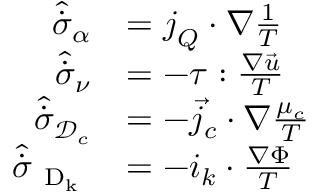Convert formula to latex. <formula><loc_0><loc_0><loc_500><loc_500>\begin{array} { r l } { \hat { \dot { \sigma } } _ { \alpha } } & { = j _ { Q } \cdot { \nabla } { \frac { 1 } { T } } } \\ { \hat { \dot { \sigma } } _ { \nu } } & { = - \tau \colon \frac { \nabla \vec { u } } { T } } \\ { \hat { \dot { \sigma } } _ { \mathcal { D } _ { c } } } & { = - { \vec { j } _ { c } } \cdot { \nabla } \frac { \mu _ { c } } { T } } \\ { \hat { \dot { \sigma } } _ { D _ { k } } } & { = - i _ { k } \cdot \frac { \nabla \Phi } { T } } \end{array}</formula> 